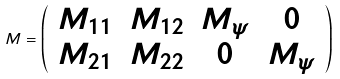Convert formula to latex. <formula><loc_0><loc_0><loc_500><loc_500>M = \left ( \begin{array} { c c c c } M _ { 1 1 } & M _ { 1 2 } & M _ { \psi } & 0 \\ M _ { 2 1 } & M _ { 2 2 } & 0 & M _ { \psi } \end{array} \right )</formula> 